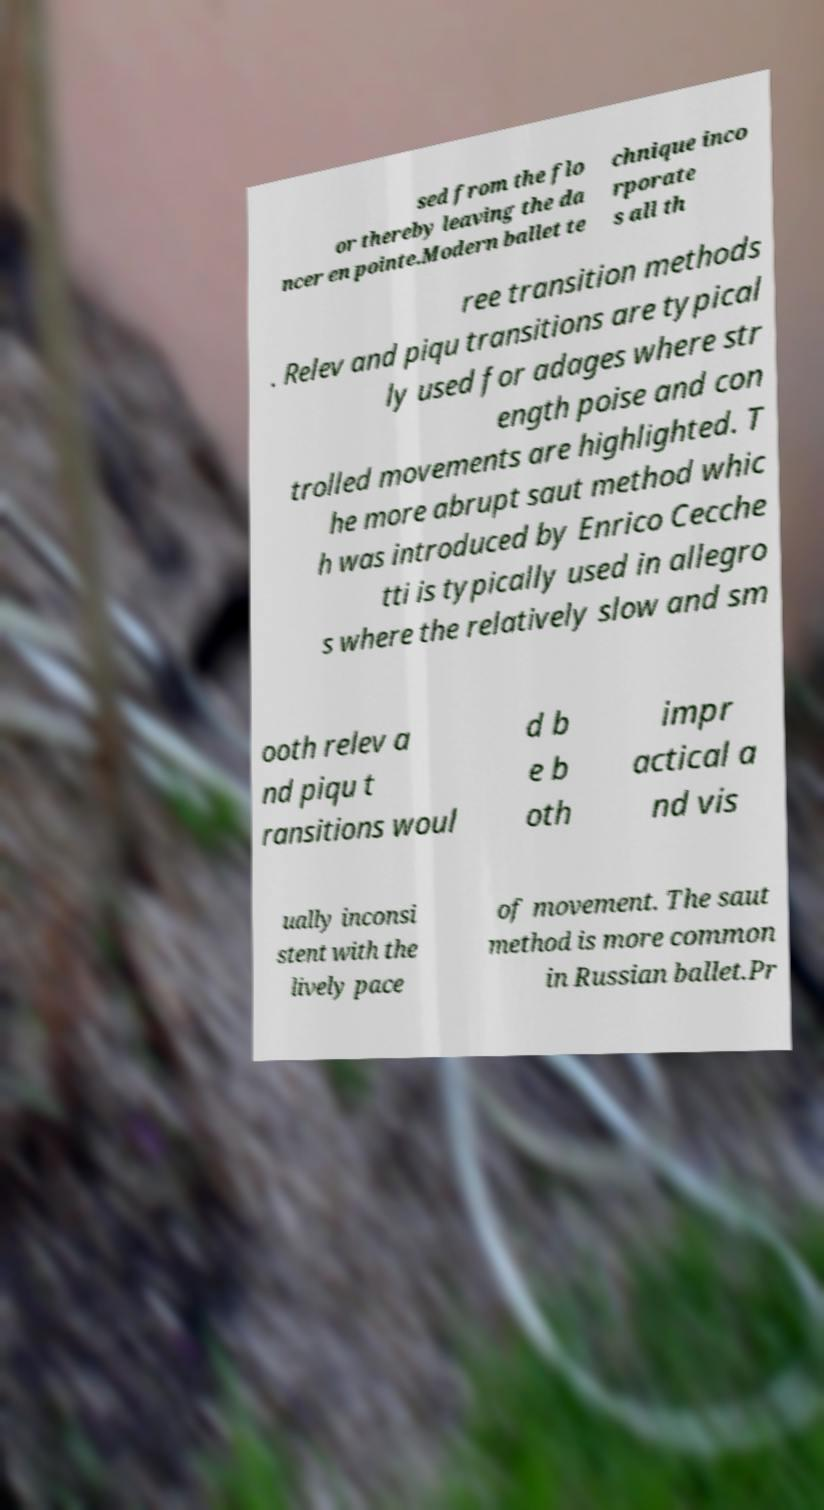Could you assist in decoding the text presented in this image and type it out clearly? sed from the flo or thereby leaving the da ncer en pointe.Modern ballet te chnique inco rporate s all th ree transition methods . Relev and piqu transitions are typical ly used for adages where str ength poise and con trolled movements are highlighted. T he more abrupt saut method whic h was introduced by Enrico Cecche tti is typically used in allegro s where the relatively slow and sm ooth relev a nd piqu t ransitions woul d b e b oth impr actical a nd vis ually inconsi stent with the lively pace of movement. The saut method is more common in Russian ballet.Pr 